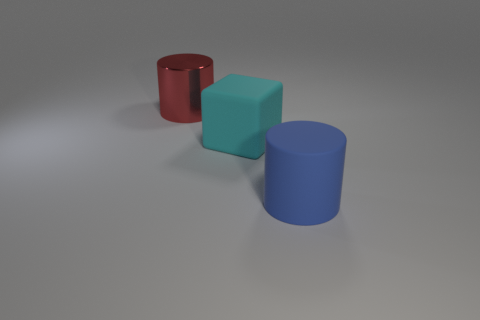What color is the large metallic thing?
Offer a very short reply. Red. There is a red metal thing to the left of the cyan rubber cube; how big is it?
Your answer should be compact. Large. There is a big object to the right of the large cyan matte block; are there any blue things that are on the right side of it?
Provide a succinct answer. No. Is the color of the large cylinder in front of the large shiny object the same as the large matte object to the left of the blue thing?
Your answer should be compact. No. There is a metal thing that is the same size as the block; what color is it?
Your answer should be very brief. Red. Is the number of blue things that are behind the large blue cylinder the same as the number of big blue matte cylinders that are behind the big matte block?
Your response must be concise. Yes. There is a big cylinder that is behind the big cylinder on the right side of the large red shiny thing; what is its material?
Provide a succinct answer. Metal. What number of things are either red shiny balls or big red things?
Provide a short and direct response. 1. Is the number of large gray cylinders less than the number of large cyan things?
Give a very brief answer. Yes. There is a cylinder that is the same material as the cyan cube; what size is it?
Ensure brevity in your answer.  Large. 